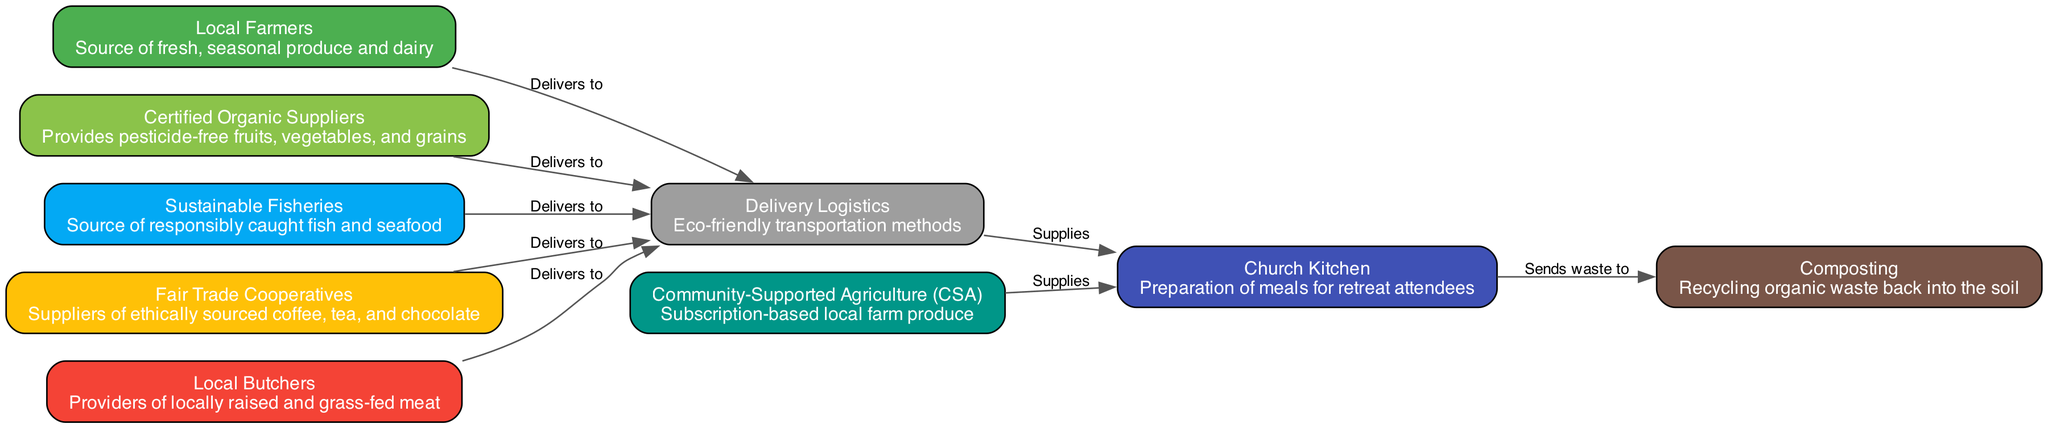What are the two types of food providers that deliver to the church kitchen? From the diagram, we can see that both "Local Farmers" and "Community-Supported Agriculture (CSA)" directly supply fresh produce to the "Church Kitchen."
Answer: Local Farmers, Community-Supported Agriculture How many nodes are in the food sourcing chain? Counting all the nodes listed in the diagram, we find nine distinct nodes representing various aspects of the food sourcing chain.
Answer: 9 What type of waste does the church kitchen send for recycling? The diagram indicates that the waste sent from the "Church Kitchen" goes to the "Composting" node, which focuses on recycling organic waste back into the soil.
Answer: Organic waste What is the role of "Delivery Logistics" in the food chain? The "Delivery Logistics" node is responsible for eco-friendly transportation methods, allowing all the suppliers (farmers, fisheries, butchers, etc.) to deliver their products to the church kitchen.
Answer: Transportation Which suppliers provide ethically sourced products? The "Fair Trade Cooperatives" node is highlighted as the supplier of ethically sourced coffee, tea, and chocolate, making them the focal point for ethical sourcing in this chain.
Answer: Fair Trade Cooperatives Which type of supplier provides pesticide-free products? The "Certified Organic Suppliers" node clearly indicates its role in providing pesticide-free fruits, vegetables, and grains, making them the answer to this question.
Answer: Certified Organic Suppliers What connects all suppliers to the church kitchen? All suppliers are connected to the "Church Kitchen" through the "Delivery Logistics" node, which indicates that all products from various providers are delivered to the kitchen via eco-friendly transport.
Answer: Delivery Logistics How many edges connect suppliers to the delivery logistics? By counting the edges leading from the different supplier nodes to "Delivery Logistics," we find that there are five connections in total.
Answer: 5 What happens to waste from the church kitchen? The diagram indicates that the waste from the "Church Kitchen" is sent to the "Composting" node, signifying that food waste is recycled back into the soil.
Answer: Sent to Composting 